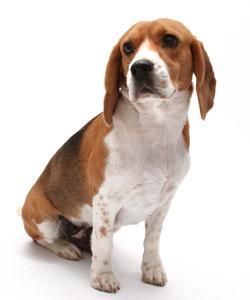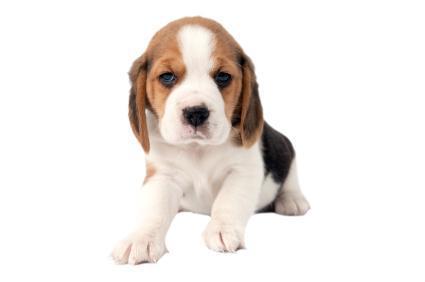The first image is the image on the left, the second image is the image on the right. For the images shown, is this caption "both dogs are sitting with its front legs up." true? Answer yes or no. No. 